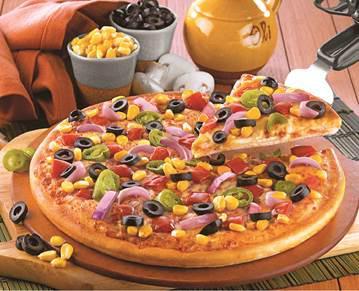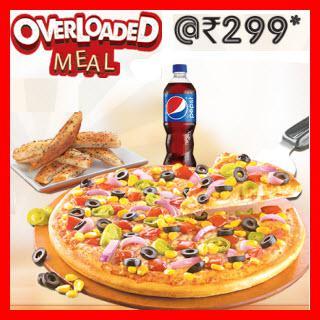The first image is the image on the left, the second image is the image on the right. For the images shown, is this caption "A single bottle of soda sits near pizza in the image on the right." true? Answer yes or no. Yes. The first image is the image on the left, the second image is the image on the right. Given the left and right images, does the statement "There are two bottles of soda pictured." hold true? Answer yes or no. No. 